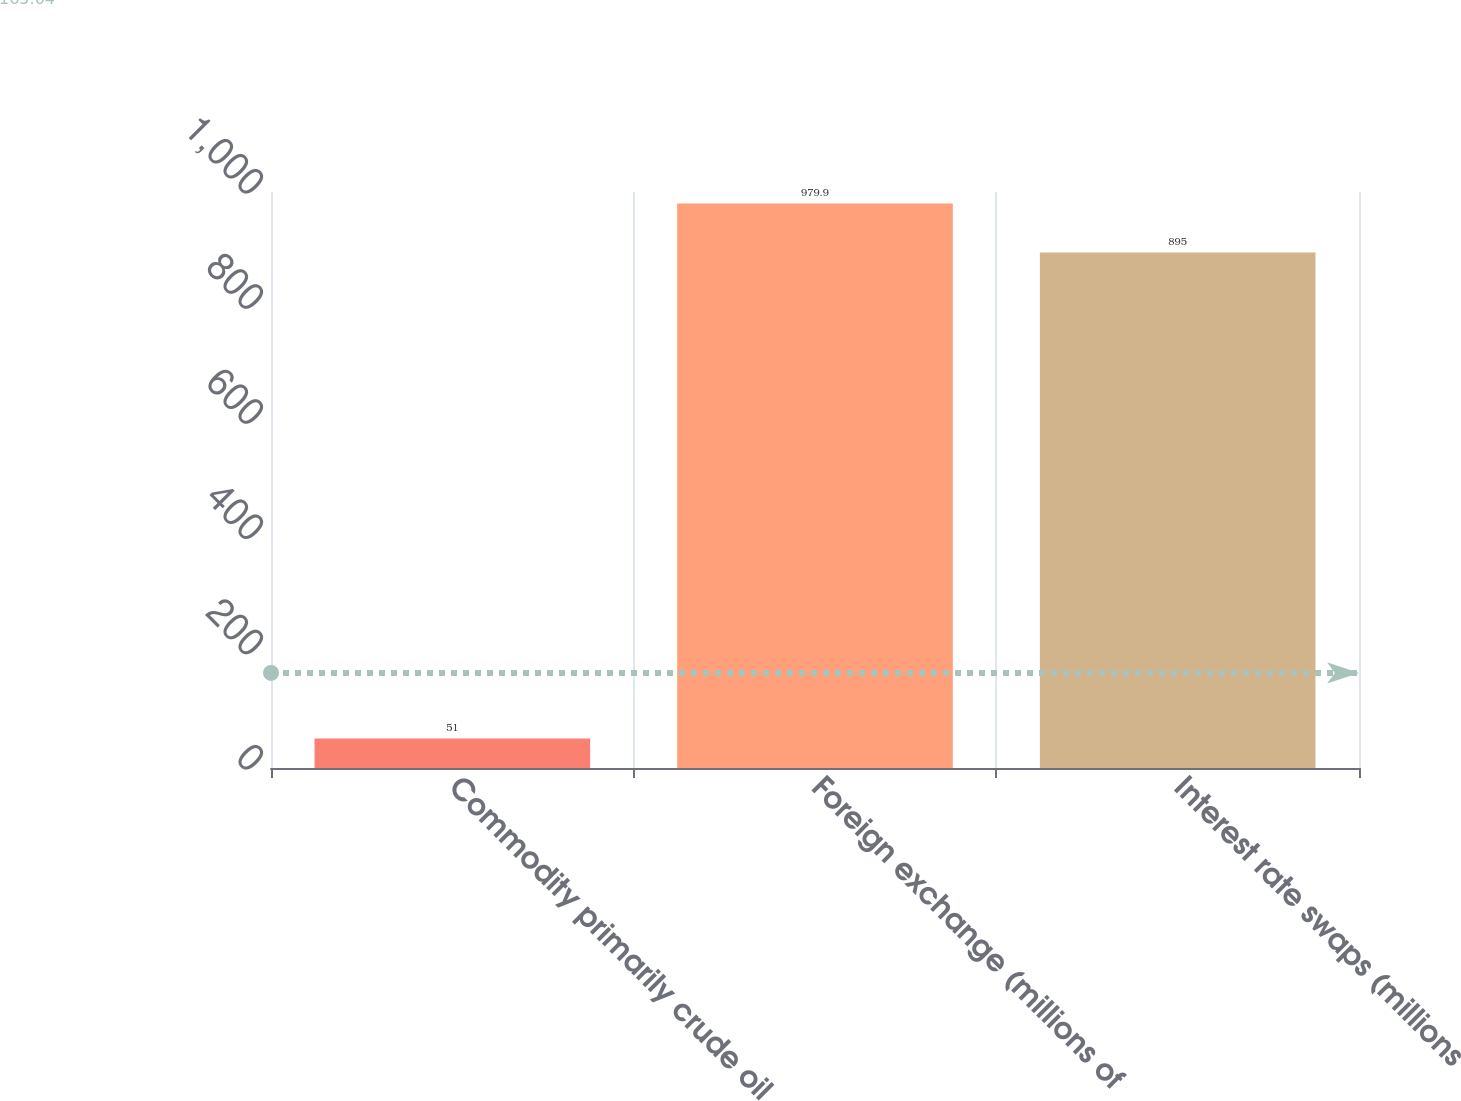Convert chart to OTSL. <chart><loc_0><loc_0><loc_500><loc_500><bar_chart><fcel>Commodity primarily crude oil<fcel>Foreign exchange (millions of<fcel>Interest rate swaps (millions<nl><fcel>51<fcel>979.9<fcel>895<nl></chart> 